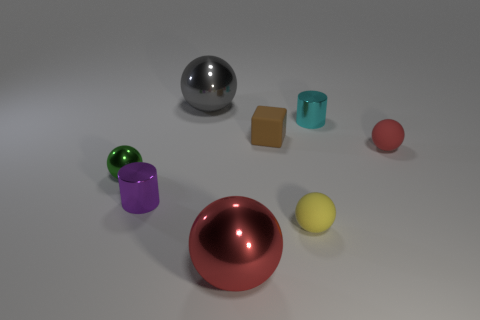Add 1 small cyan cylinders. How many objects exist? 9 Subtract all gray metallic spheres. How many spheres are left? 4 Subtract all cyan cylinders. How many cylinders are left? 1 Subtract 0 yellow cylinders. How many objects are left? 8 Subtract all balls. How many objects are left? 3 Subtract 3 balls. How many balls are left? 2 Subtract all yellow spheres. Subtract all gray blocks. How many spheres are left? 4 Subtract all yellow cylinders. How many purple balls are left? 0 Subtract all red balls. Subtract all red rubber balls. How many objects are left? 5 Add 3 tiny matte spheres. How many tiny matte spheres are left? 5 